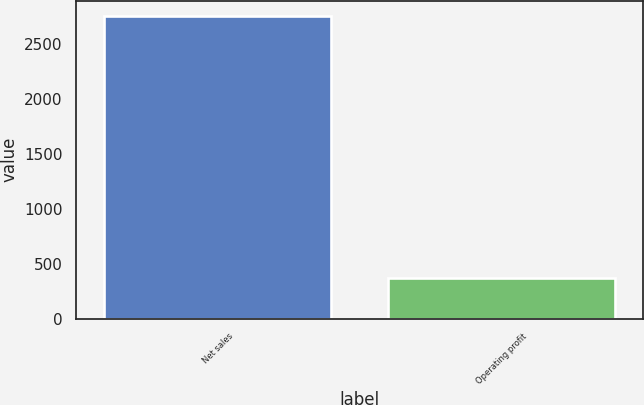<chart> <loc_0><loc_0><loc_500><loc_500><bar_chart><fcel>Net sales<fcel>Operating profit<nl><fcel>2756<fcel>370<nl></chart> 